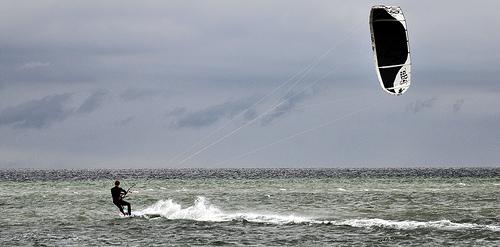Question: who is in the picture?
Choices:
A. A woman.
B. A boy.
C. A man.
D. A girl.
Answer with the letter. Answer: C Question: what color is the wetsuit?
Choices:
A. Green.
B. Blue.
C. Yellow.
D. Black.
Answer with the letter. Answer: D Question: what is the man standing on?
Choices:
A. A surfboard.
B. A snowboard.
C. Skis.
D. A kiteboard.
Answer with the letter. Answer: D Question: where is the kite?
Choices:
A. The ground.
B. In the tree.
C. The air.
D. In her hand.
Answer with the letter. Answer: C Question: what color is the sky?
Choices:
A. Blue.
B. Gray.
C. White.
D. Yellow.
Answer with the letter. Answer: B 